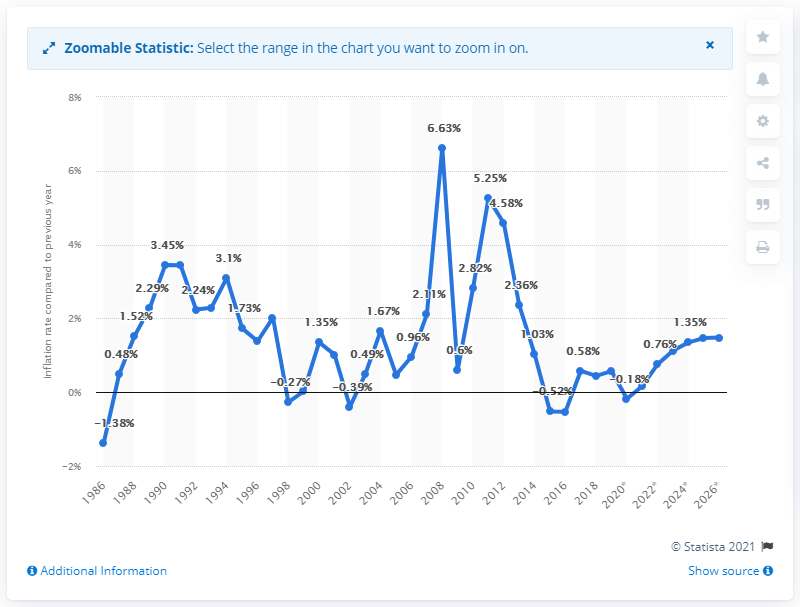Outline some significant characteristics in this image. The projected inflation rate for Singapore in 2026 is 1.48%. 